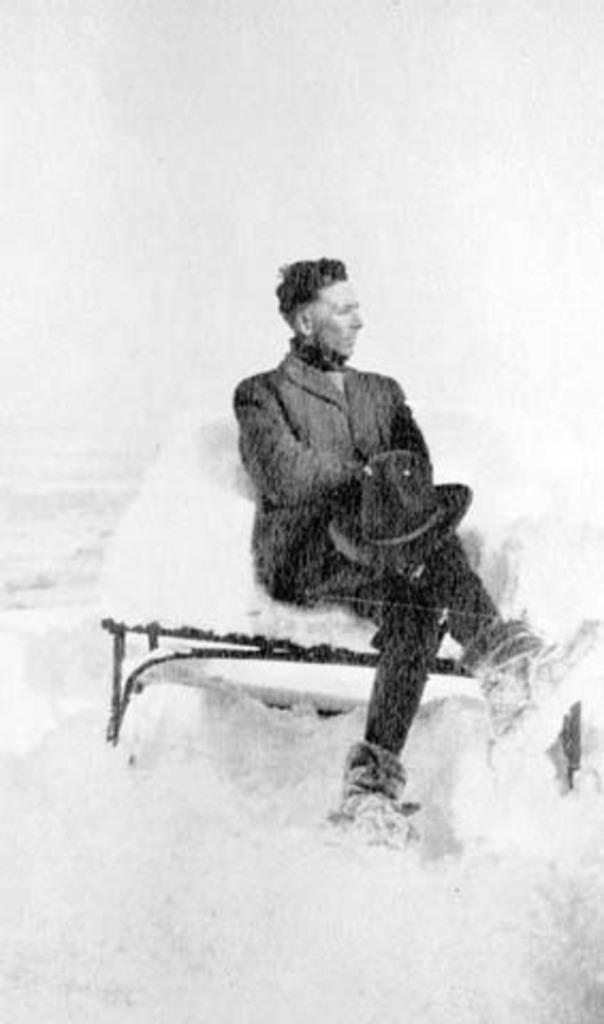How would you summarize this image in a sentence or two? In this image we can see a person sitting on a bench and he is holding a hat. There is a snow in the image. 